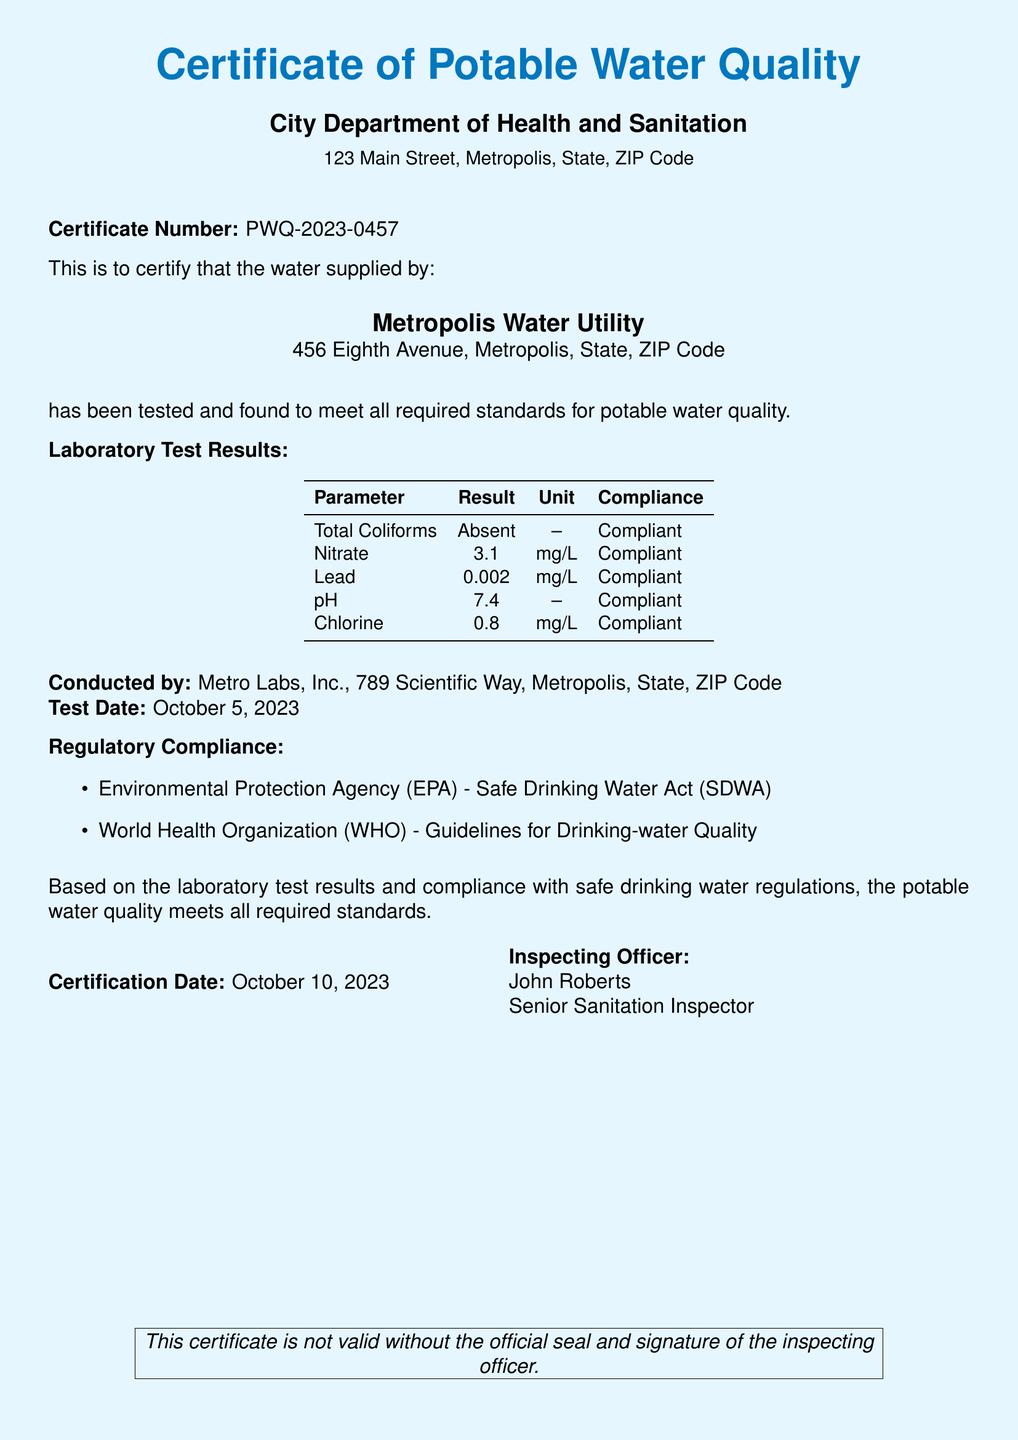what is the certificate number? The certificate number is a unique identifier for the document, which is specified in the text as PWQ-2023-0457.
Answer: PWQ-2023-0457 who is the inspecting officer? The inspecting officer is mentioned at the bottom of the document, specifically named as John Roberts.
Answer: John Roberts when was the certification date? The certification date is the date mentioned at the end of the certificate, which is noted as October 10, 2023.
Answer: October 10, 2023 what laboratory conducted the water test? The name of the laboratory that conducted the water tests is stated in the document as Metro Labs, Inc.
Answer: Metro Labs, Inc what is the lead concentration result? The lead concentration is provided in the laboratory test results section, specifically stated as 0.002 mg/L.
Answer: 0.002 mg/L what regulatory guidelines are referenced? The document mentions compliance with the Environmental Protection Agency's Safe Drinking Water Act and World Health Organization guidelines, indicating multiple standards.
Answer: EPA and WHO what was the test date? The test date is noted in the laboratory test details of the document as October 5, 2023.
Answer: October 5, 2023 how many parameters were tested? By counting the rows in the laboratory test results table, we can ascertain the number of parameters tested, which totals five.
Answer: five 